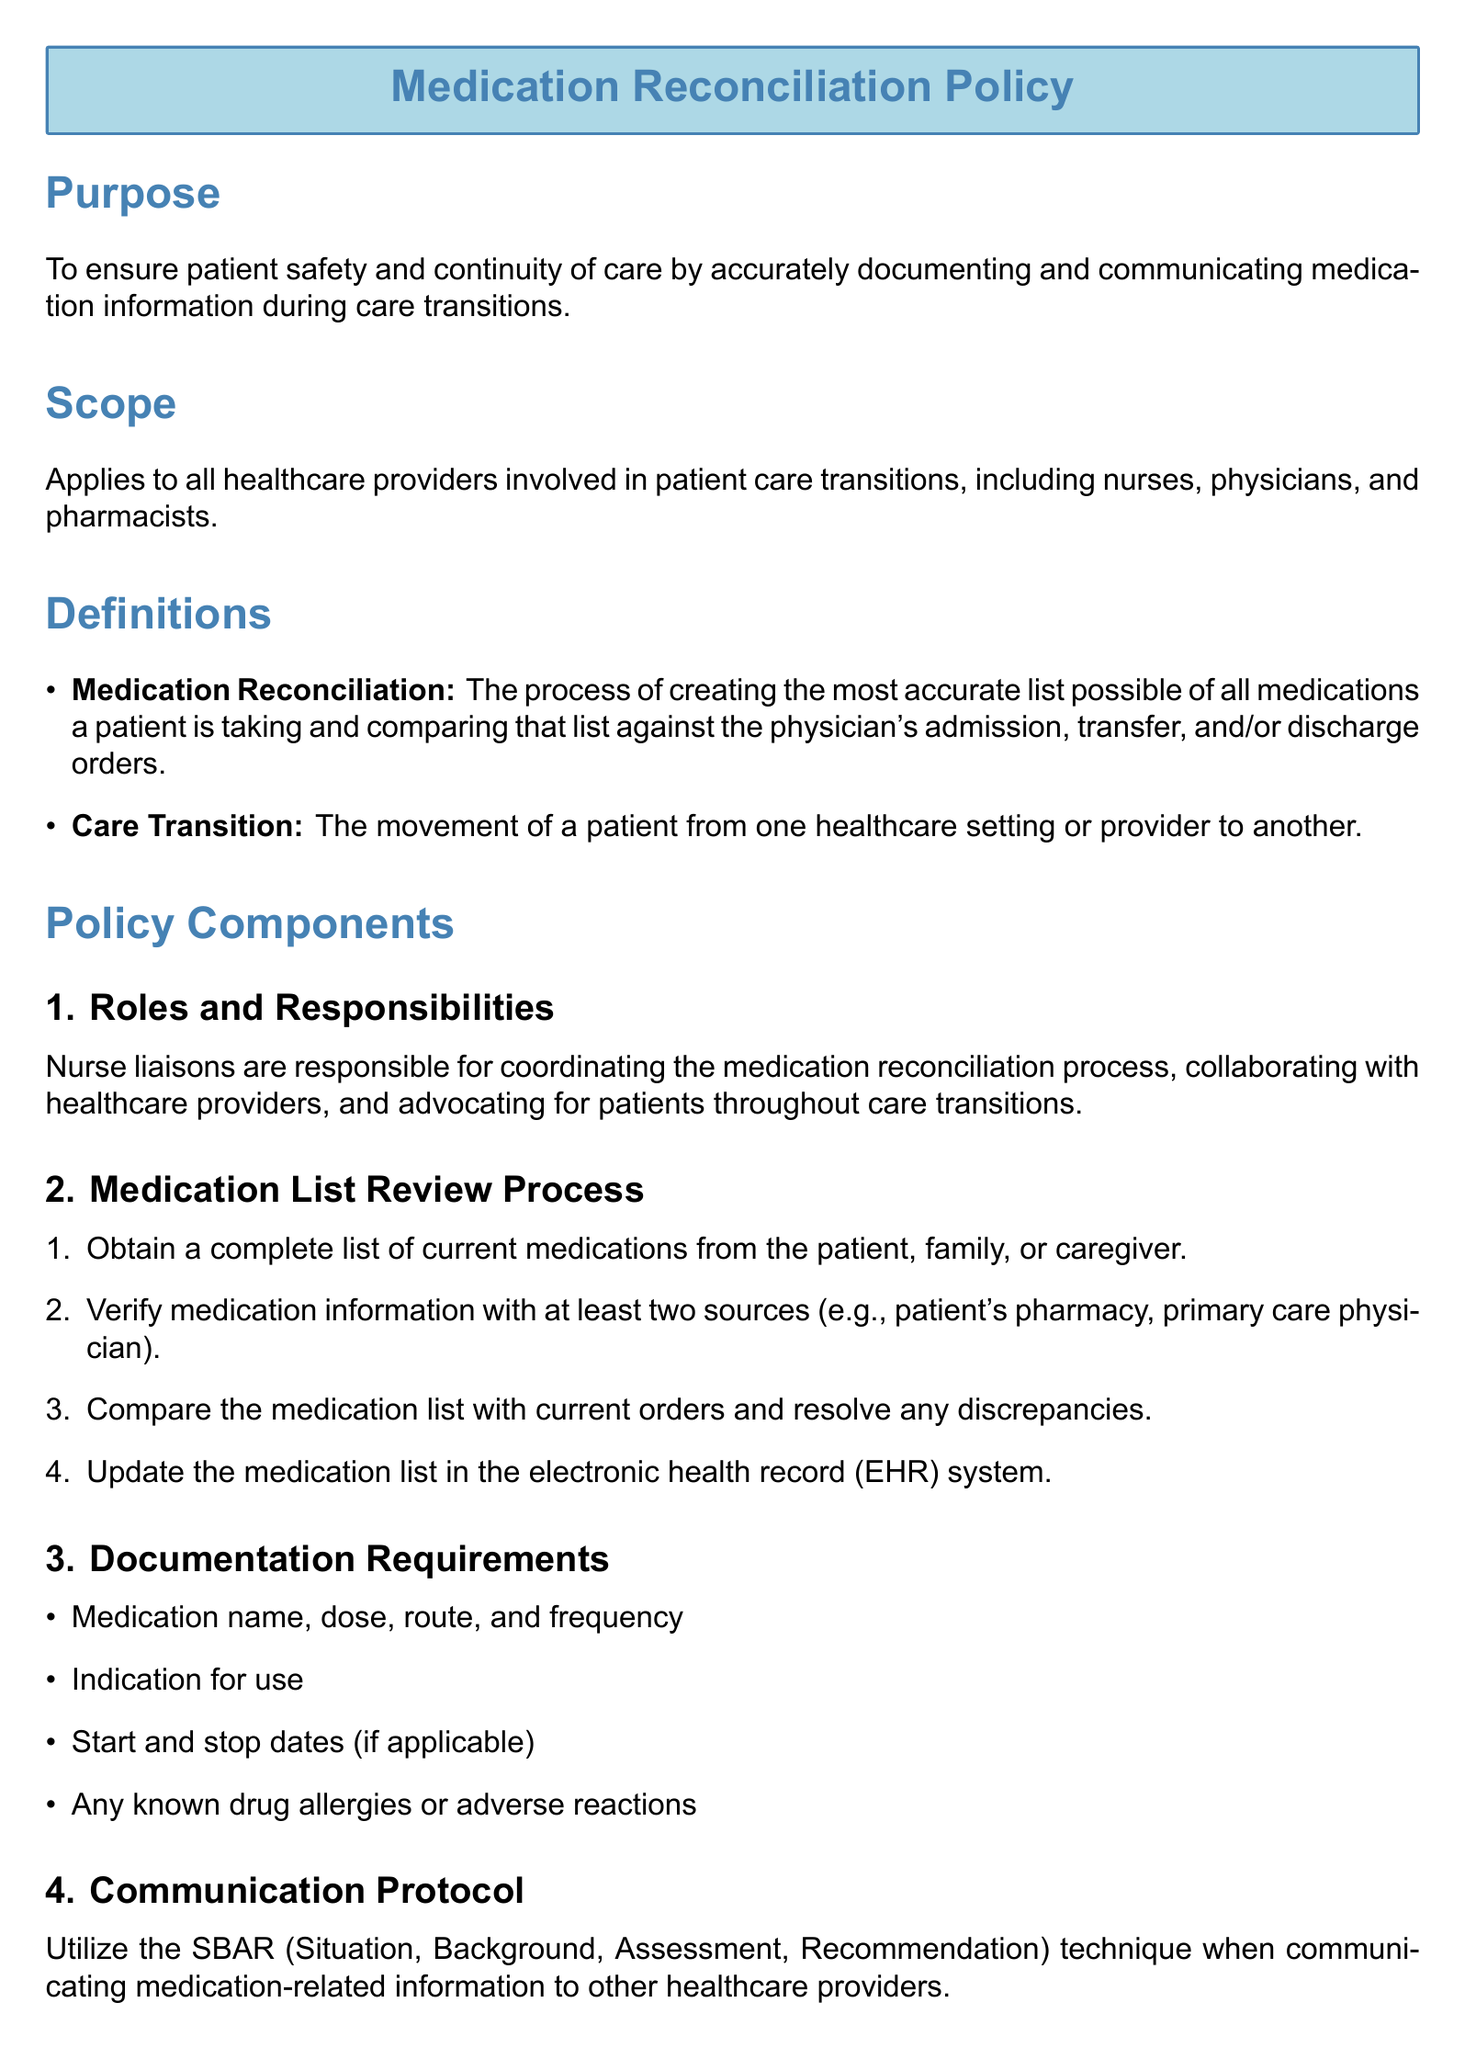What is the purpose of the Medication Reconciliation Policy? The purpose is to ensure patient safety and continuity of care by accurately documenting and communicating medication information during care transitions.
Answer: To ensure patient safety and continuity of care Who is responsible for coordinating the medication reconciliation process? The document states that nurse liaisons are responsible for coordinating the medication reconciliation process.
Answer: Nurse liaisons What is the first step in the medication list review process? The first step is to obtain a complete list of current medications from the patient, family, or caregiver.
Answer: Obtain a complete list of current medications What technique should be used for communicating medication-related information? The document specifies utilizing the SBAR technique for communication.
Answer: SBAR What annual action is required regarding the policy? The policy requires an annual review and update by the Pharmacy and Therapeutics Committee.
Answer: Annual review and update What information is required to be documented about each medication? Required documentation includes medication name, dose, route, frequency, indication for use, start and stop dates, and any known drug allergies or adverse reactions.
Answer: Medication name, dose, route, frequency, indication for use How many sources should be used to verify medication information? The document stipulates that medication information should be verified with at least two sources.
Answer: Two sources What kind of education should be provided to patients? Patients should be provided with an updated medication list and educated on changes, potential side effects, and proper administration techniques.
Answer: Updated medication list and education on changes 